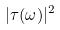Convert formula to latex. <formula><loc_0><loc_0><loc_500><loc_500>| \tau ( \omega ) | ^ { 2 }</formula> 